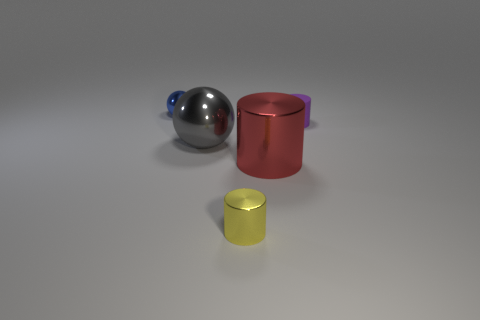Add 1 blue shiny things. How many objects exist? 6 Subtract all spheres. How many objects are left? 3 Subtract 0 yellow balls. How many objects are left? 5 Subtract all blue metal cylinders. Subtract all shiny cylinders. How many objects are left? 3 Add 4 small blue balls. How many small blue balls are left? 5 Add 5 rubber things. How many rubber things exist? 6 